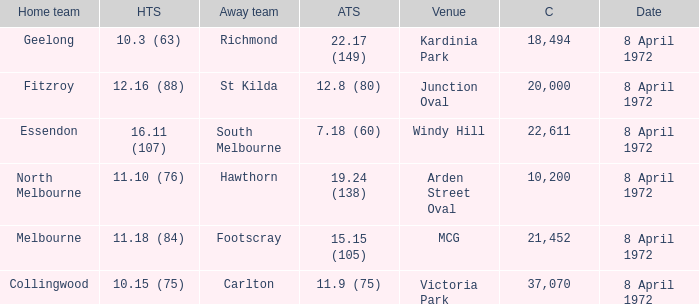Which Venue has a Home team of geelong? Kardinia Park. 